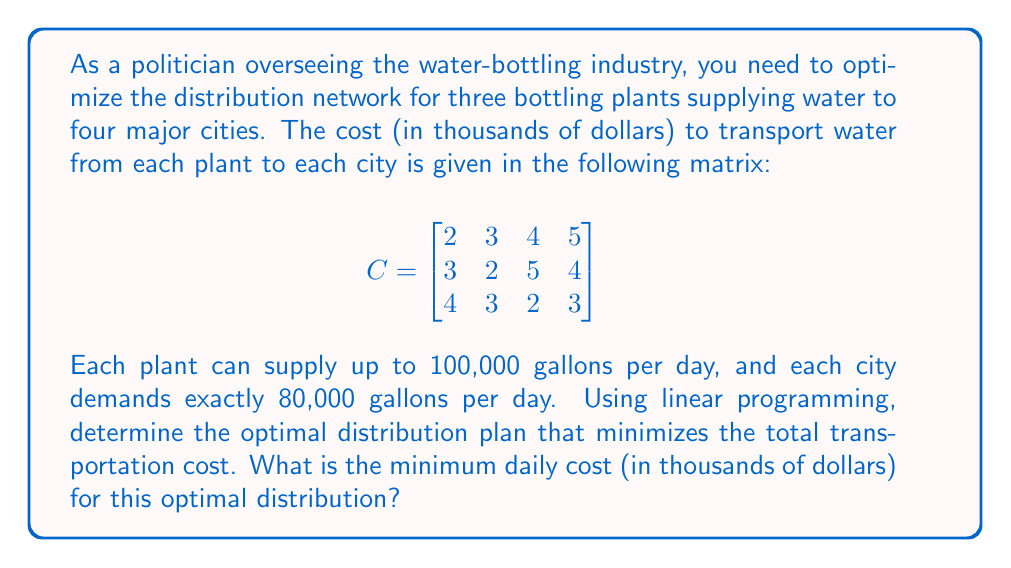Provide a solution to this math problem. To solve this problem, we need to use linear programming. Let's follow these steps:

1) Define variables:
   Let $x_{ij}$ be the amount of water (in thousands of gallons) transported from plant i to city j.

2) Objective function:
   Minimize the total cost: 
   $$Z = 2x_{11} + 3x_{12} + 4x_{13} + 5x_{14} + 3x_{21} + 2x_{22} + 5x_{23} + 4x_{24} + 4x_{31} + 3x_{32} + 2x_{33} + 3x_{34}$$

3) Constraints:
   - Supply constraints (≤ 100 for each plant):
     $$x_{11} + x_{12} + x_{13} + x_{14} \leq 100$$
     $$x_{21} + x_{22} + x_{23} + x_{24} \leq 100$$
     $$x_{31} + x_{32} + x_{33} + x_{34} \leq 100$$
   
   - Demand constraints (= 80 for each city):
     $$x_{11} + x_{21} + x_{31} = 80$$
     $$x_{12} + x_{22} + x_{32} = 80$$
     $$x_{13} + x_{23} + x_{33} = 80$$
     $$x_{14} + x_{24} + x_{34} = 80$$

   - Non-negativity constraints:
     $$x_{ij} \geq 0$$ for all i and j

4) Solve using linear programming software or the simplex method. The optimal solution is:

   $$x_{11} = 80, x_{22} = 80, x_{33} = 80, x_{34} = 20$$
   All other $x_{ij} = 0$

5) Calculate the minimum cost:
   $$Z_{min} = 2(80) + 2(80) + 2(80) + 3(20) = 480$$

Therefore, the minimum daily cost is 480 thousand dollars.
Answer: $480,000 